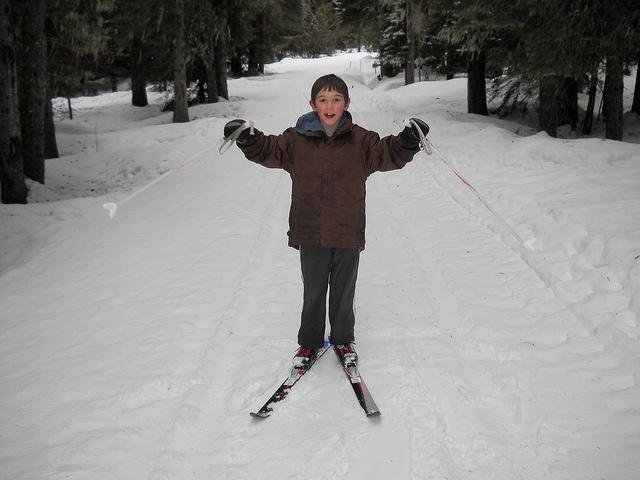How many ski poles are stuck into the snow?
Give a very brief answer. 0. How many cows are here?
Give a very brief answer. 0. 